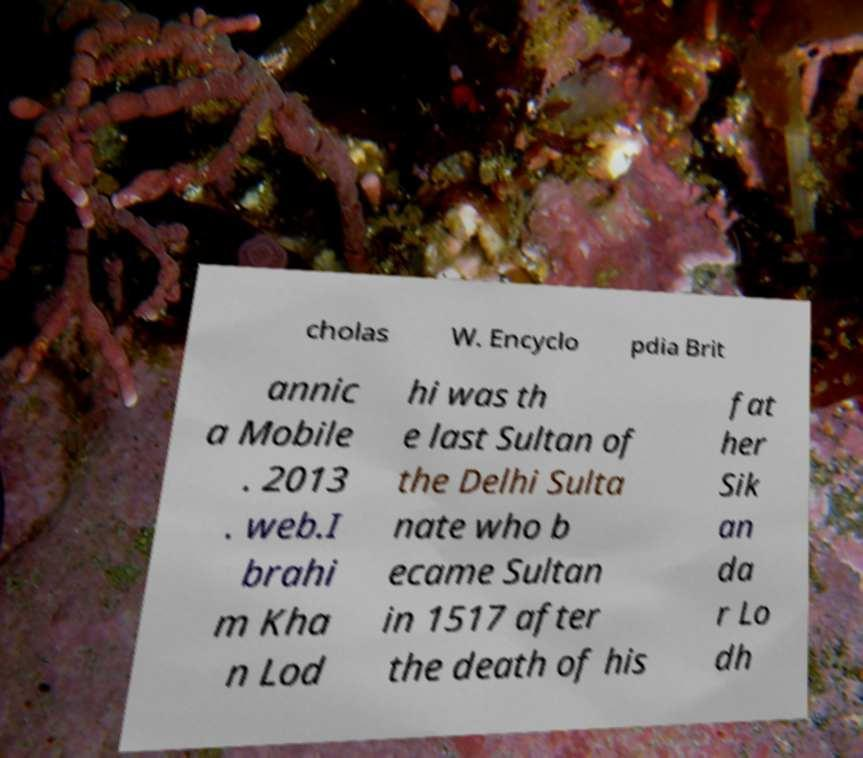Please read and relay the text visible in this image. What does it say? cholas W. Encyclo pdia Brit annic a Mobile . 2013 . web.I brahi m Kha n Lod hi was th e last Sultan of the Delhi Sulta nate who b ecame Sultan in 1517 after the death of his fat her Sik an da r Lo dh 